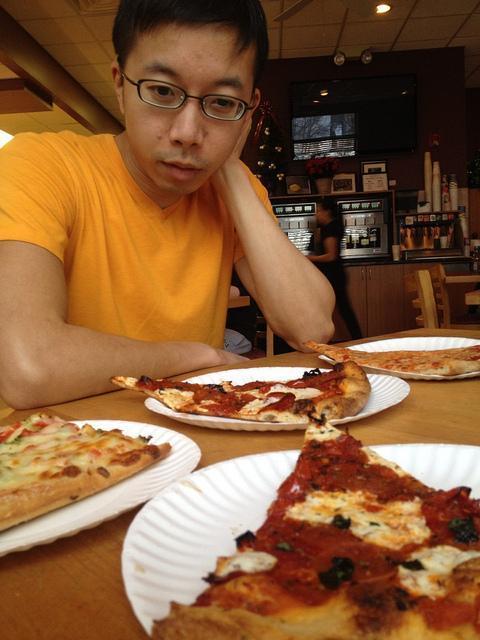How many pizzas are there?
Give a very brief answer. 4. How many people can you see?
Give a very brief answer. 2. 